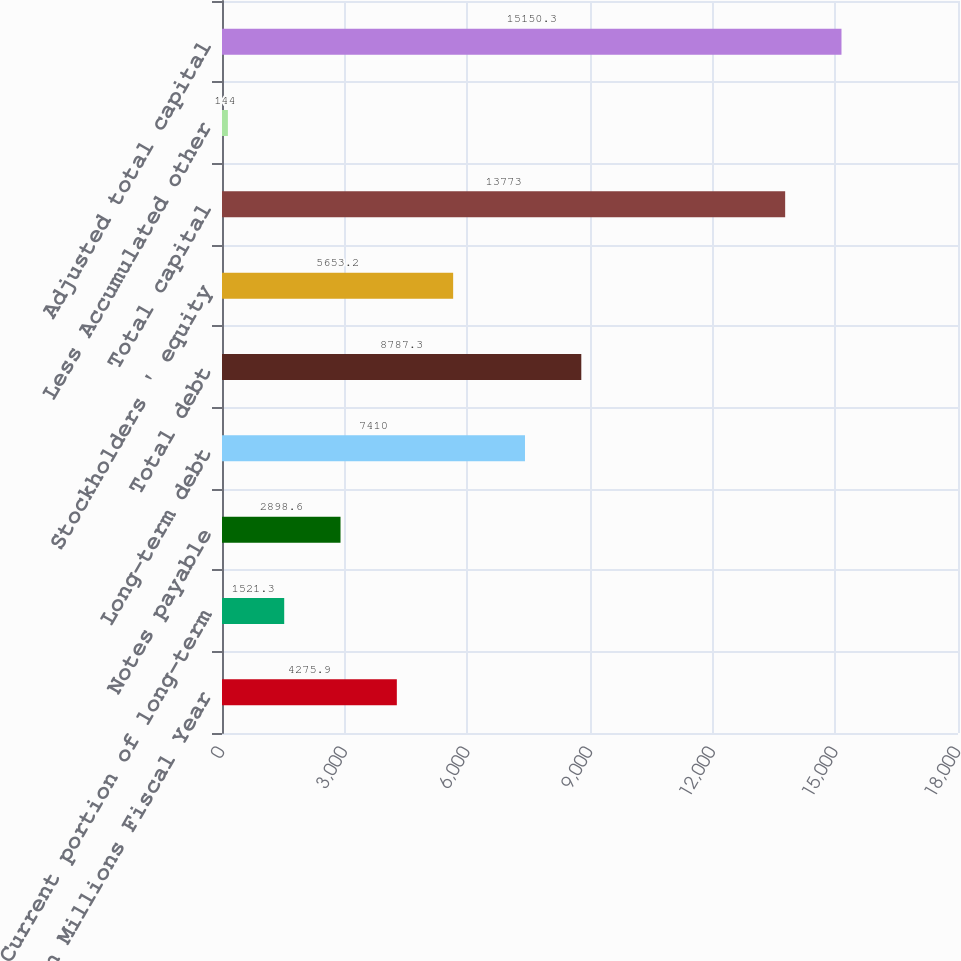<chart> <loc_0><loc_0><loc_500><loc_500><bar_chart><fcel>In Millions Fiscal Year<fcel>Current portion of long-term<fcel>Notes payable<fcel>Long-term debt<fcel>Total debt<fcel>Stockholders ' equity<fcel>Total capital<fcel>Less Accumulated other<fcel>Adjusted total capital<nl><fcel>4275.9<fcel>1521.3<fcel>2898.6<fcel>7410<fcel>8787.3<fcel>5653.2<fcel>13773<fcel>144<fcel>15150.3<nl></chart> 